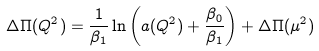Convert formula to latex. <formula><loc_0><loc_0><loc_500><loc_500>\Delta \Pi ( Q ^ { 2 } ) = \frac { 1 } { \beta _ { 1 } } \ln \left ( a ( Q ^ { 2 } ) + \frac { \beta _ { 0 } } { \beta _ { 1 } } \right ) + \Delta \Pi ( \mu ^ { 2 } )</formula> 